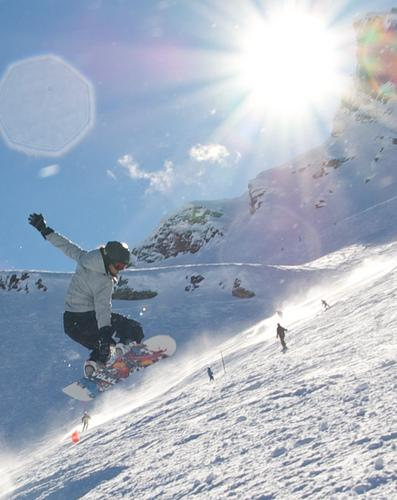What is the notable condition of the snow in the image?  The snow appears to be well traversed and very bright white. Describe the snowboard design and color. The snowboard is white with multi-color designs. How many white clouds are there in the blue sky of the image? There are 9 white clouds in the blue sky. List the colors of the sky, sun, and clouds in the image. Blue sky, yellow sun, and white clouds. Based on the image, what can you infer about the location? It's a mountain side with a ski slope and majestic mountains in the distance. What general actions and sentiments are portrayed in the image? A snowboarder in midair with helmet and goggles, snowboarding on a snowy hill, surrounded by scenic mountains and skiers, giving feelings of excitement, adventure, and beauty. Identify the three prominent colors of the snowboarder's outfit. White jacket, black pants, and black gloves. What is the snowboarder wearing on their head and face? The snowboarder is wearing a black helmet and face goggles. How many skiers or boarders are in the background of the image? There are 5 skiers or boarders in the background. What is happening in the sky of the image? There is a yellow sun, white clouds in the blue sky, and sun rays with lens flare. How is the snowboarder interacting with the snow? Snowboarding on a snowy hill, midair Rate the quality of the image on a scale of 1 to 10, considering its clarity and composition. 8 Detect any unusual elements in the image. Lens flare in the sky Describe the condition of the snow in the image. Well traversed, bright white, roughed up What does the sun look like in this photo? Yellow with sun rays in the blue sky List the prominent colors in the image. Bright white, blue, multi-color, yellow, black Does the image have any text or characters? No Are there other skiers/boarders besides the main subject? Yes, 5 skiers/boarders are in the background Is the snowboarder wearing any gloves? Yes, black gloves What are the main colors of the snowboard? White with multi-color designs Which three tasks are most relevant to this image? Image captioning, Object Detection, Image Sentiment Analysis What are the main activities depicted in the image? Snowboarding,skiing What is Jackson Mingus' role in this image? Photographer What safety equipment is the snowboarder wearing? Helmet and goggles Find the person who is wearing a blue coat. X:205 Y:370 Width:27 Height:27 Locate the instance of low flying clouds in the image. X:128 Y:144 Width:166 Height:166 Identify the main action in the photo. Snowboarding 